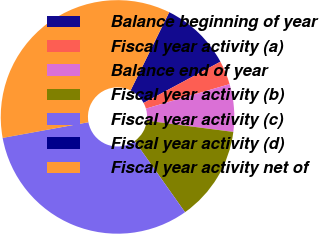Convert chart to OTSL. <chart><loc_0><loc_0><loc_500><loc_500><pie_chart><fcel>Balance beginning of year<fcel>Fiscal year activity (a)<fcel>Balance end of year<fcel>Fiscal year activity (b)<fcel>Fiscal year activity (c)<fcel>Fiscal year activity (d)<fcel>Fiscal year activity net of<nl><fcel>9.86%<fcel>3.31%<fcel>6.58%<fcel>13.14%<fcel>31.9%<fcel>0.03%<fcel>35.18%<nl></chart> 